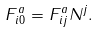Convert formula to latex. <formula><loc_0><loc_0><loc_500><loc_500>F ^ { a } _ { i 0 } = F ^ { a } _ { i j } N ^ { j } .</formula> 